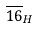<formula> <loc_0><loc_0><loc_500><loc_500>\overline { 1 6 } _ { H }</formula> 